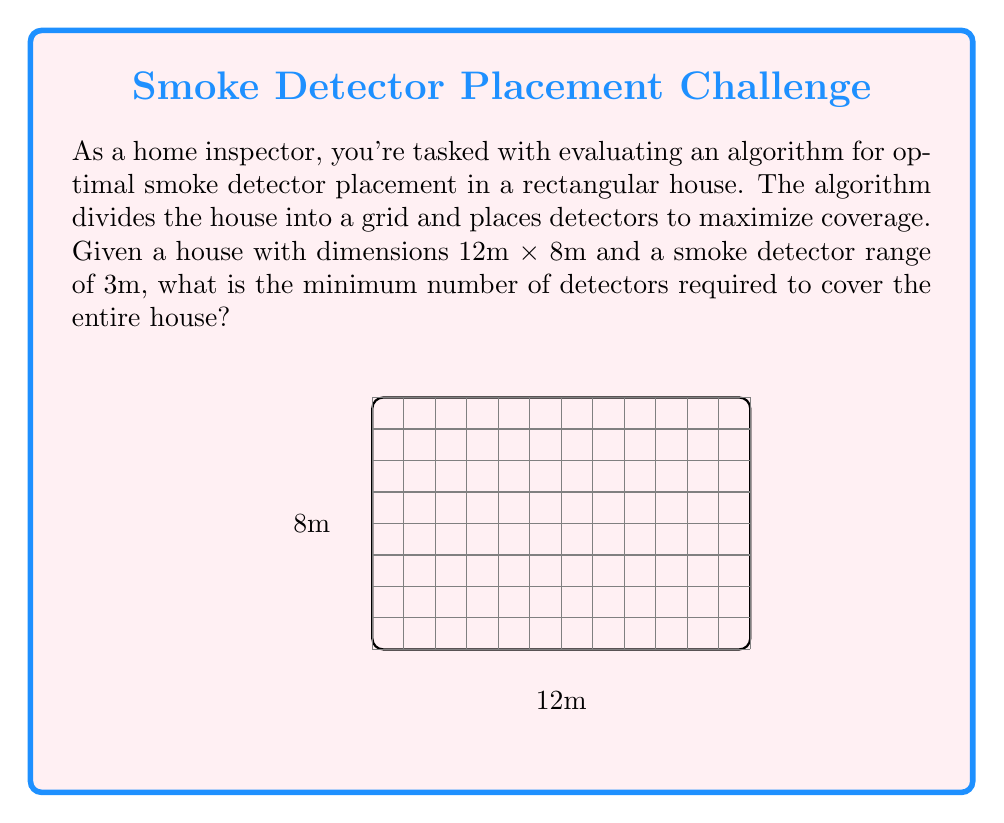Can you solve this math problem? Let's approach this step-by-step:

1) First, we need to understand the coverage area of each detector. With a range of 3m, each detector covers a circular area with a diameter of 6m.

2) To simplify the problem, we can consider the square coverage of each detector, which is 6m x 6m.

3) Now, we need to determine how many 6m x 6m squares can fit into the 12m x 8m house:

   - Along the length: $\lceil \frac{12}{6} \rceil = 2$ detectors
   - Along the width: $\lceil \frac{8}{6} \rceil = 2$ detectors

   Where $\lceil x \rceil$ denotes the ceiling function (rounding up to the nearest integer).

4) The total number of detectors needed is thus:

   $2 \times 2 = 4$ detectors

5) To verify, let's check if this covers the entire house:
   - 4 detectors, each covering 6m x 6m = 36m²
   - Total area covered: $4 \times 36\text{m}² = 144\text{m}²$
   - House area: $12\text{m} \times 8\text{m} = 96\text{m}²$

   The coverage area (144m²) is greater than the house area (96m²), confirming full coverage.

Therefore, the minimum number of detectors required is 4.
Answer: 4 detectors 